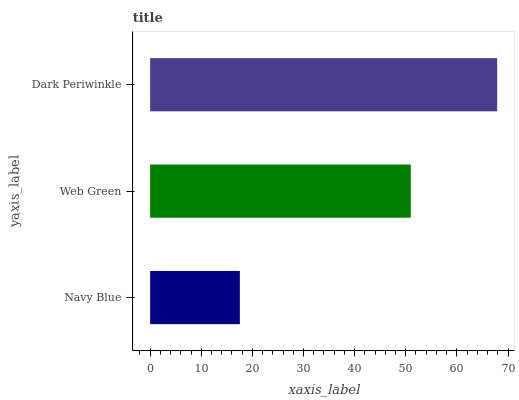Is Navy Blue the minimum?
Answer yes or no. Yes. Is Dark Periwinkle the maximum?
Answer yes or no. Yes. Is Web Green the minimum?
Answer yes or no. No. Is Web Green the maximum?
Answer yes or no. No. Is Web Green greater than Navy Blue?
Answer yes or no. Yes. Is Navy Blue less than Web Green?
Answer yes or no. Yes. Is Navy Blue greater than Web Green?
Answer yes or no. No. Is Web Green less than Navy Blue?
Answer yes or no. No. Is Web Green the high median?
Answer yes or no. Yes. Is Web Green the low median?
Answer yes or no. Yes. Is Navy Blue the high median?
Answer yes or no. No. Is Navy Blue the low median?
Answer yes or no. No. 